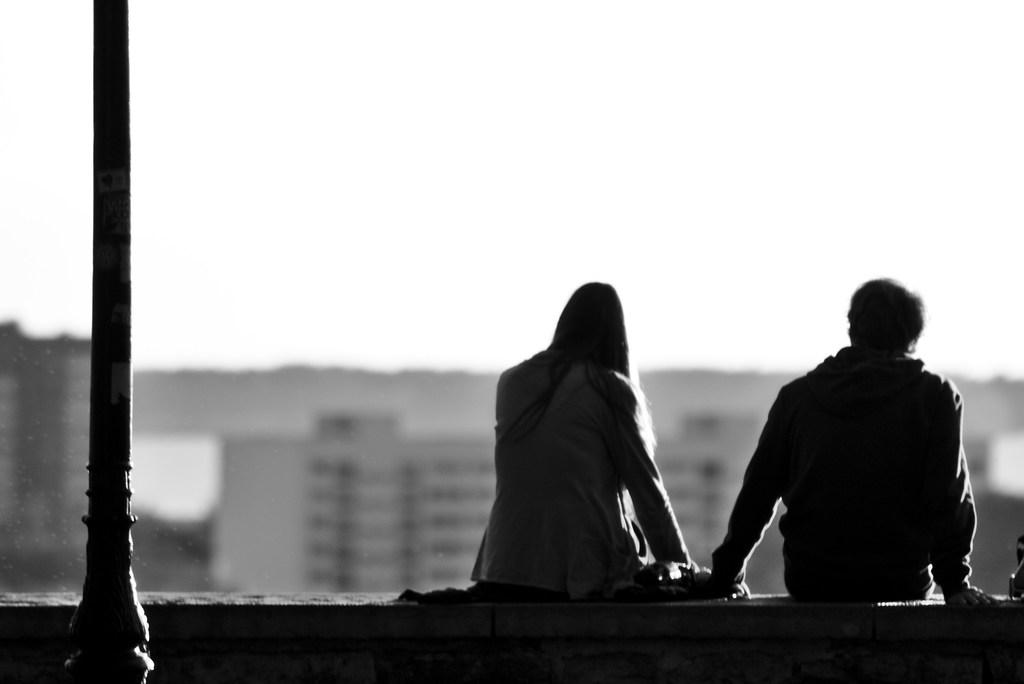How many people are present in the image? There are two people sitting in the image. What is the color scheme of the image? The image is in black and white. What object can be seen in the background or alongside the people? There is a pole visible in the image. How many beds are present in the image? There are no beds visible in the image. What type of bait is being used by the people in the image? There are no fishing activities or bait present in the image. 